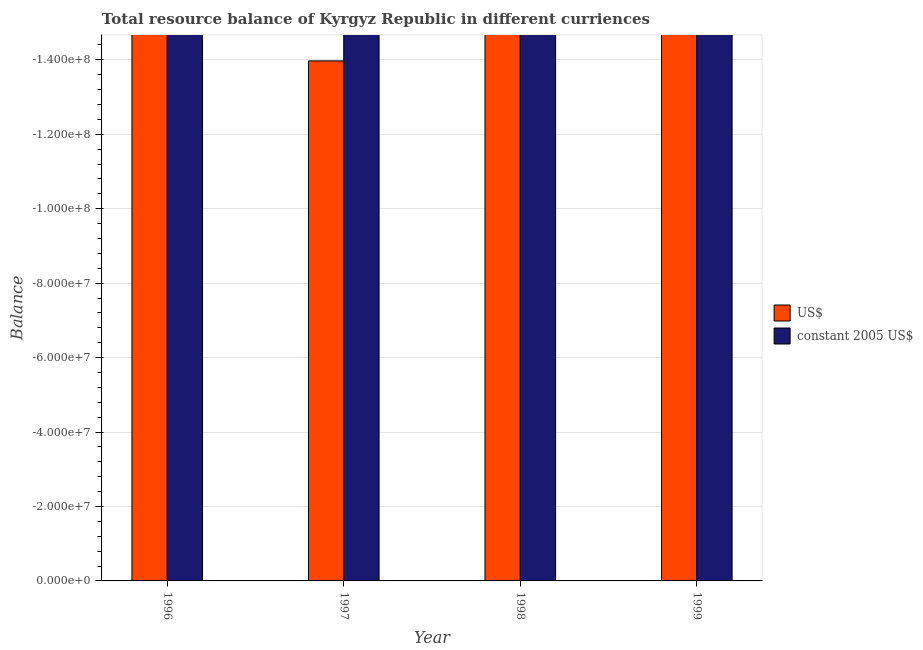How many bars are there on the 4th tick from the left?
Keep it short and to the point. 0. In how many cases, is the number of bars for a given year not equal to the number of legend labels?
Give a very brief answer. 4. Across all years, what is the minimum resource balance in us$?
Provide a short and direct response. 0. What is the total resource balance in us$ in the graph?
Provide a succinct answer. 0. What is the average resource balance in us$ per year?
Provide a short and direct response. 0. Are all the bars in the graph horizontal?
Offer a terse response. No. How many years are there in the graph?
Offer a terse response. 4. Are the values on the major ticks of Y-axis written in scientific E-notation?
Offer a very short reply. Yes. Does the graph contain any zero values?
Provide a short and direct response. Yes. Does the graph contain grids?
Keep it short and to the point. Yes. Where does the legend appear in the graph?
Provide a short and direct response. Center right. How many legend labels are there?
Ensure brevity in your answer.  2. How are the legend labels stacked?
Provide a short and direct response. Vertical. What is the title of the graph?
Your answer should be compact. Total resource balance of Kyrgyz Republic in different curriences. What is the label or title of the X-axis?
Ensure brevity in your answer.  Year. What is the label or title of the Y-axis?
Provide a short and direct response. Balance. What is the Balance of US$ in 1996?
Give a very brief answer. 0. What is the Balance in constant 2005 US$ in 1996?
Keep it short and to the point. 0. What is the Balance of constant 2005 US$ in 1997?
Keep it short and to the point. 0. What is the Balance of US$ in 1999?
Offer a terse response. 0. What is the total Balance of US$ in the graph?
Make the answer very short. 0. What is the total Balance in constant 2005 US$ in the graph?
Offer a terse response. 0. What is the average Balance in US$ per year?
Your answer should be very brief. 0. 